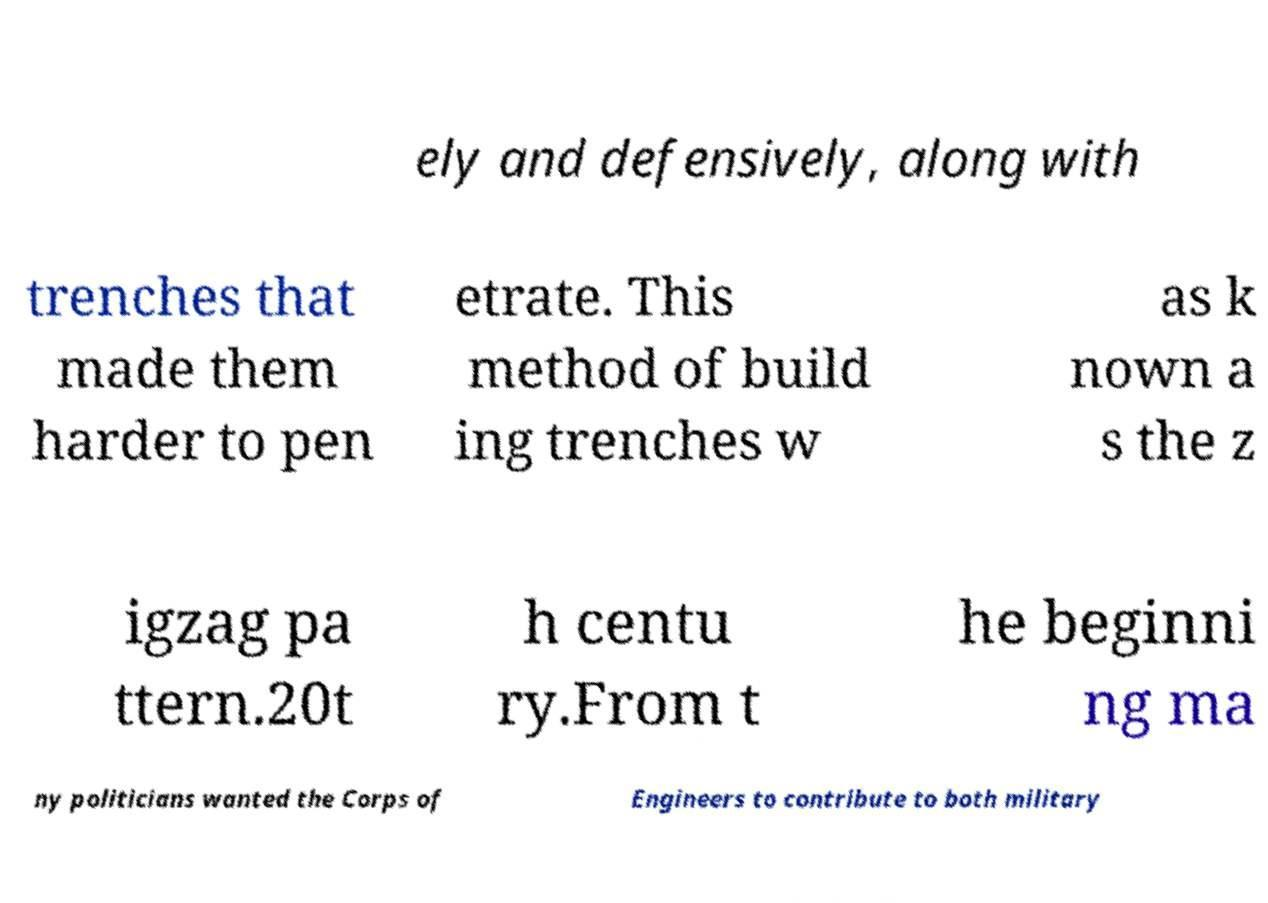Could you extract and type out the text from this image? ely and defensively, along with trenches that made them harder to pen etrate. This method of build ing trenches w as k nown a s the z igzag pa ttern.20t h centu ry.From t he beginni ng ma ny politicians wanted the Corps of Engineers to contribute to both military 